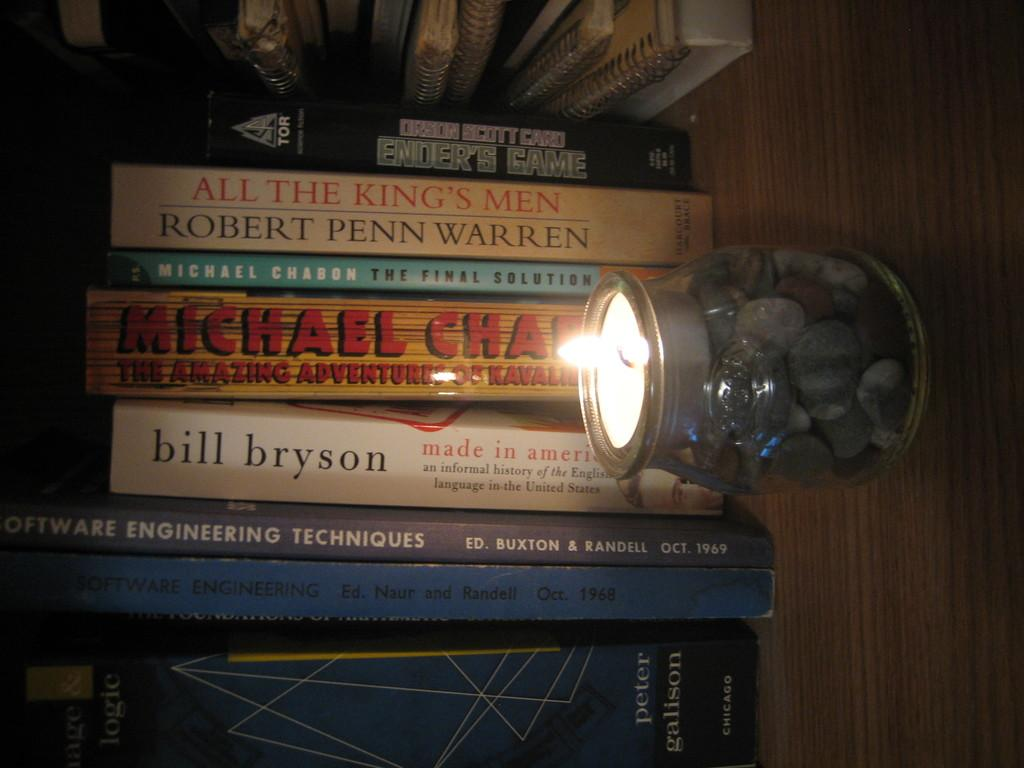<image>
Write a terse but informative summary of the picture. A collection of books on a shelf includes a copy of ENDER'S GAME by Orson Scott Card. 